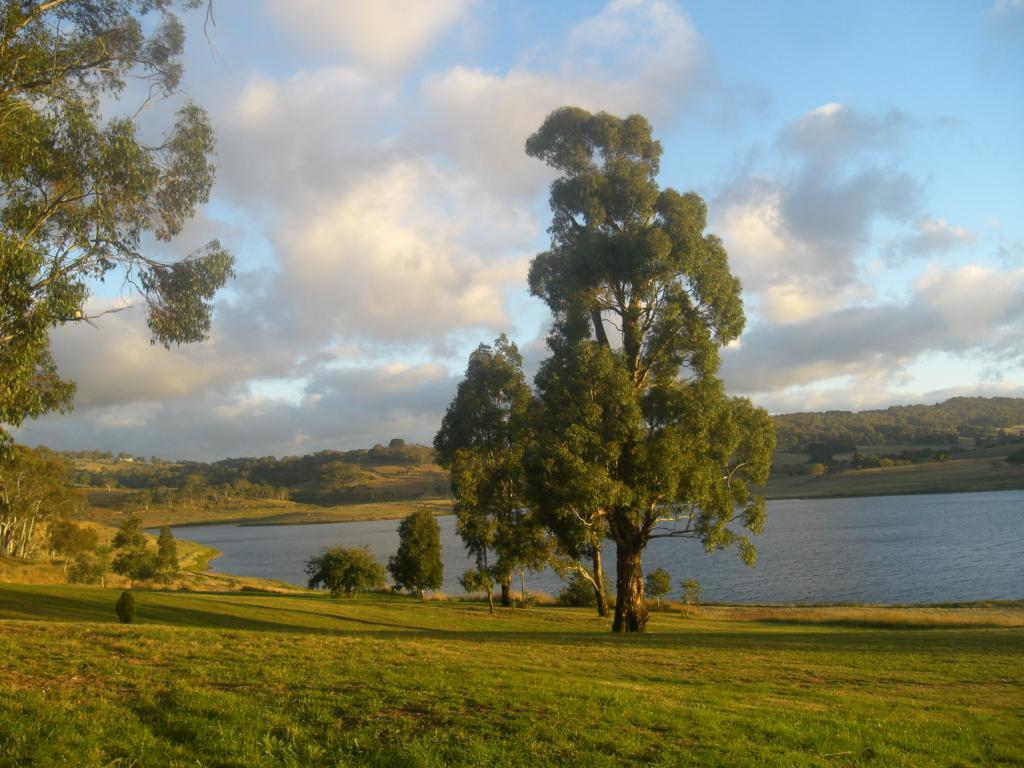What type of vegetation can be seen in the image? There are trees and plants in the image. Where are the trees and plants located? The trees and plants are on grassland. What can be seen on the right side of the image? There is water on the right side of the image. How is the water positioned in relation to the land? The water is between the land. What is visible at the top of the image? The sky is visible at the top of the image. What can be seen in the sky? There are clouds in the sky. Where is the monkey sitting while eating cheese in the image? There is no monkey or cheese present in the image. What type of cheese is being served with the trees and plants in the image? There is no cheese present in the image; it features trees, plants, grassland, water, and clouds. 